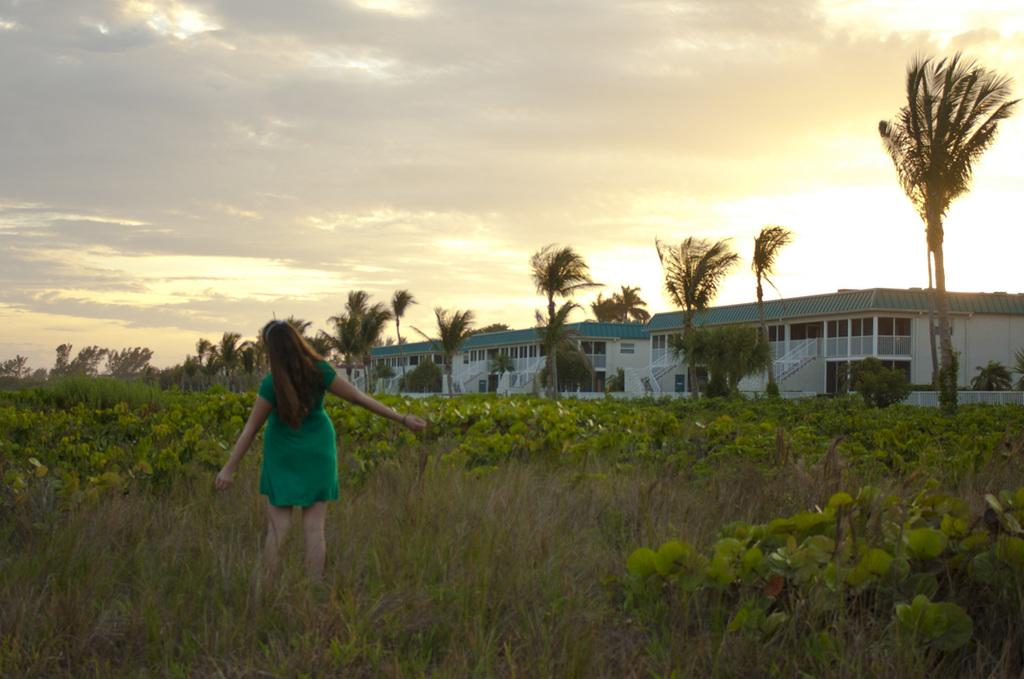What is the main subject of the image? There is a person standing in the image. What is the person wearing? The person is wearing a green dress. What can be seen in the background of the image? There are trees, buildings, and the sky visible in the background of the image. What colors are the trees in the background? The trees are green in color. What colors are the buildings in the background? The buildings are white and green in color. What is the color of the sky in the background? The sky is white and gray in color. What type of stitch is the person using to sew the dress in the image? There is no indication in the image that the person is sewing the dress or using any stitch. How does the person's behavior change throughout the image? The image is a still photograph, so the person's behavior does not change throughout the image. 